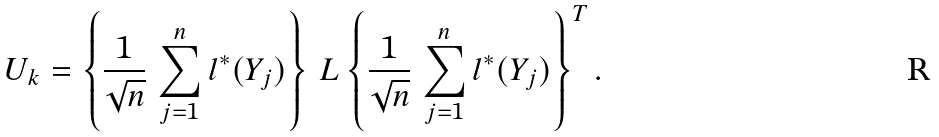<formula> <loc_0><loc_0><loc_500><loc_500>U _ { k } = \left \{ \frac { 1 } { \sqrt { n } } \, \sum _ { j = 1 } ^ { n } l ^ { \ast } ( Y _ { j } ) \right \} \, L \, { \left \{ \frac { 1 } { \sqrt { n } } \, \sum _ { j = 1 } ^ { n } l ^ { \ast } ( Y _ { j } ) \right \} } ^ { T } \, .</formula> 